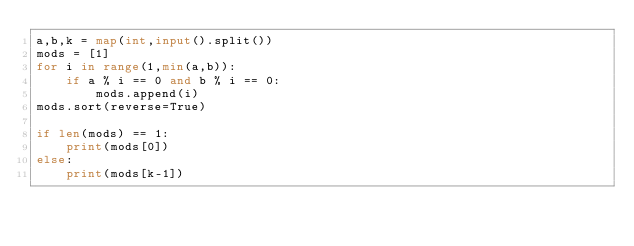<code> <loc_0><loc_0><loc_500><loc_500><_Python_>a,b,k = map(int,input().split())
mods = [1]
for i in range(1,min(a,b)):
    if a % i == 0 and b % i == 0:
        mods.append(i)
mods.sort(reverse=True)

if len(mods) == 1:
    print(mods[0])
else:
    print(mods[k-1])</code> 